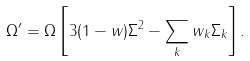<formula> <loc_0><loc_0><loc_500><loc_500>\Omega ^ { \prime } = \Omega \left [ 3 ( 1 - w ) \Sigma ^ { 2 } - \sum _ { k } w _ { k } \Sigma _ { k } \right ] .</formula> 